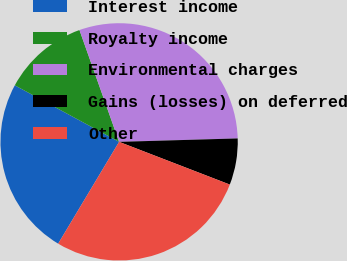<chart> <loc_0><loc_0><loc_500><loc_500><pie_chart><fcel>Interest income<fcel>Royalty income<fcel>Environmental charges<fcel>Gains (losses) on deferred<fcel>Other<nl><fcel>24.32%<fcel>11.67%<fcel>29.96%<fcel>6.32%<fcel>27.72%<nl></chart> 